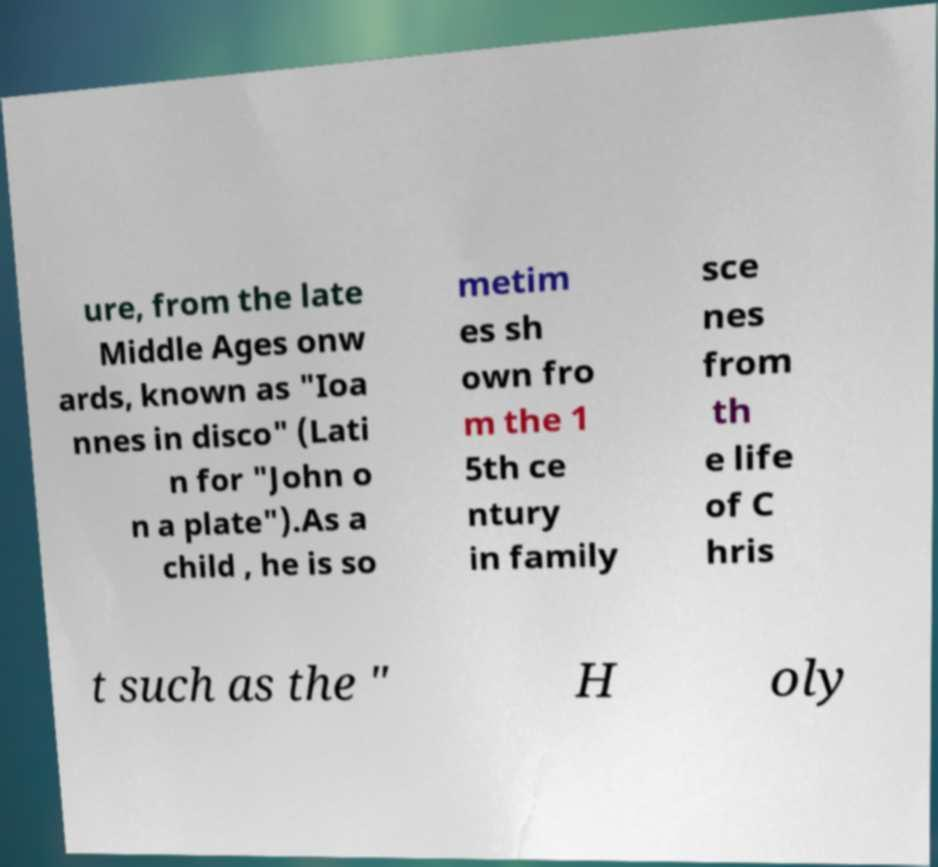For documentation purposes, I need the text within this image transcribed. Could you provide that? ure, from the late Middle Ages onw ards, known as "Ioa nnes in disco" (Lati n for "John o n a plate").As a child , he is so metim es sh own fro m the 1 5th ce ntury in family sce nes from th e life of C hris t such as the " H oly 